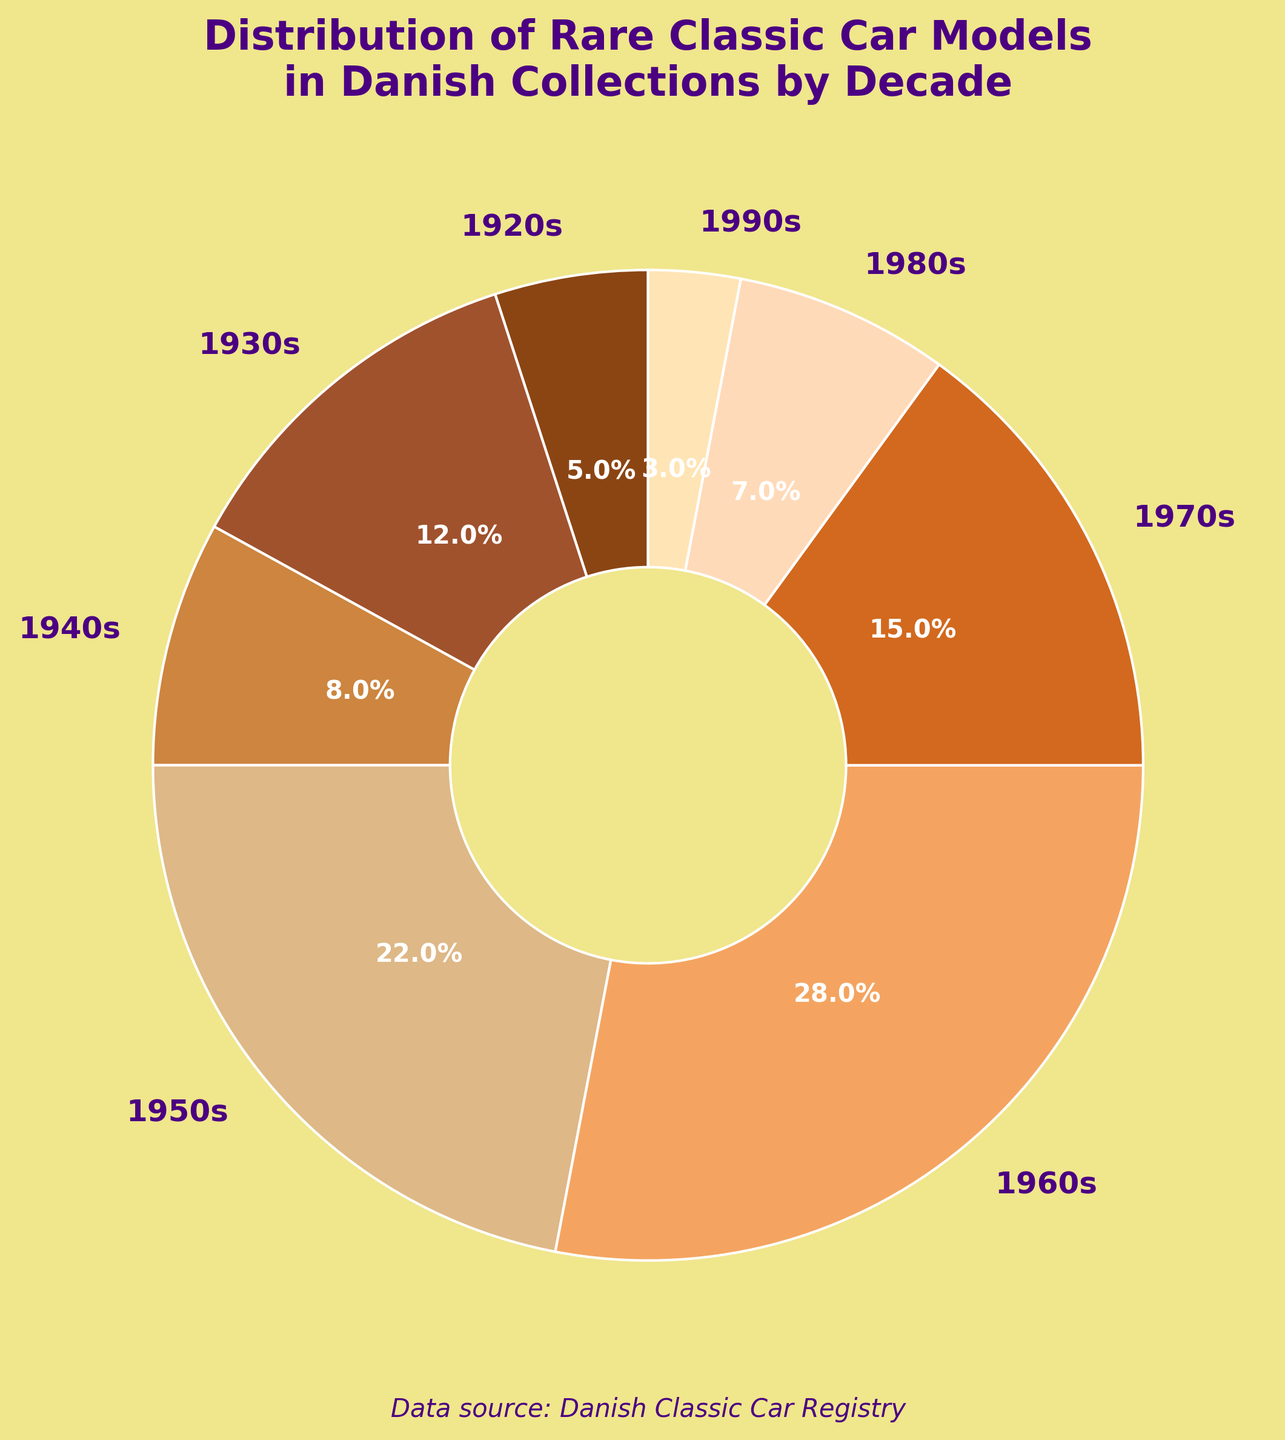What percentage of rare classic car models in Danish collections were manufactured in the 1950s? Locate the slice labeled "1950s" on the pie chart and read the percentage value displayed.
Answer: 22% Which decade has the highest representation of rare classic car models in Danish collections, and what percentage does it hold? Find the largest slice on the pie chart and check the label and percentage for that slice.
Answer: 1960s, 28% Compare the representation of the 1940s with the 1970s. Which decade has a higher percentage, and by how much? Find the slices labeled "1940s" and "1970s" and note their percentages (8% and 15%, respectively). Subtract the smaller percentage from the larger one.
Answer: 1970s by 7% What is the combined percentage of rare classic car models from the 1920s and 1980s in Danish collections? Find the slices labeled "1920s" and "1980s" and add their percentages (5% + 7%).
Answer: 12% Which decade has the smallest representation of rare classic car models in Danish collections, and what is its percentage? Identify the smallest slice on the pie chart and read its label and percentage.
Answer: 1990s, 3% How much more is the percentage of rare classic car models from the 1960s compared to the 1980s? Find the slices labeled "1960s" and "1980s" and subtract the percentage of the 1980s from that of the 1960s (28% - 7%).
Answer: 21% What are the percentages of decades represented by shades of brown color, and which hues are they exactly? Observe the color shades in the pie chart, identifying which slices have brownish hues and their corresponding labels and percentages (shades for 1920s: 5%, 1930s: 12%, 1940s: 8%, 1950s: 22%, 1960s: 28%, 1970s: 15%, 1980s: 7%, and 1990s: 3%).
Answer: Multiple brown shades totaling 100% By how much does the percentage of the 1950s exceed the combined percentages of the 1920s and 1990s? Find the slices for the 1950s, 1920s, and 1990s, and calculate their percentages. Substract the combined percentages of the 1920s and 1990s from the percentage of the 1950s (22% - (5% + 3%)).
Answer: 14% What is the average percentage of rare classic car models from the 1970s, 1980s, and 1990s? Add the percentages of the 1970s, 1980s, and 1990s and divide by 3 ((15% + 7% + 3%) / 3)).
Answer: 8.3% 